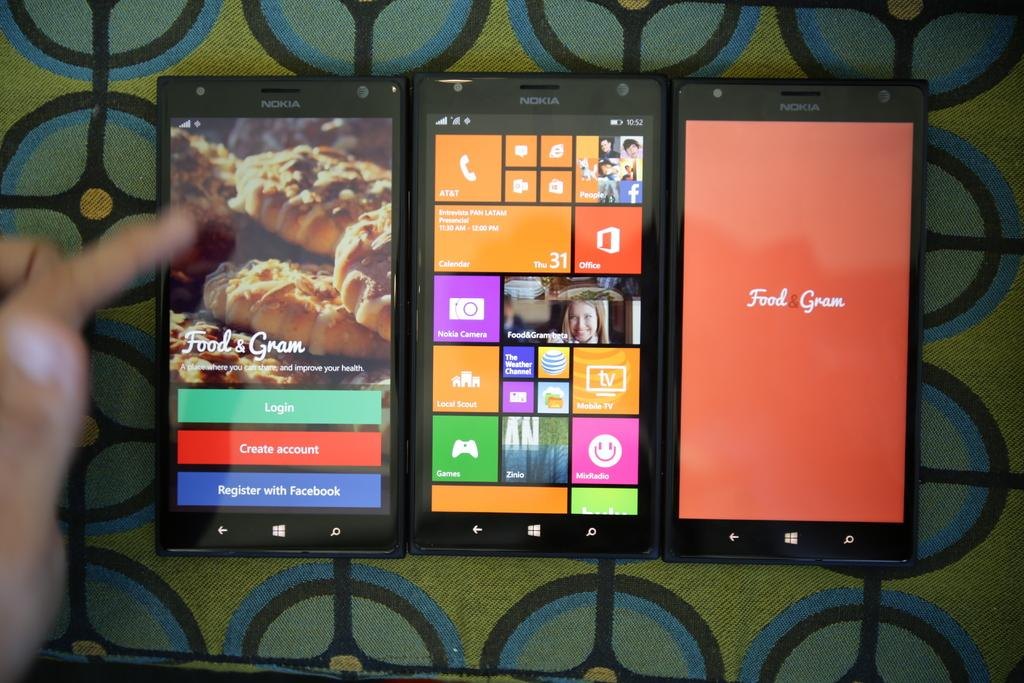<image>
Provide a brief description of the given image. Three devices in a row, the two on the ends say Food & Gram. 